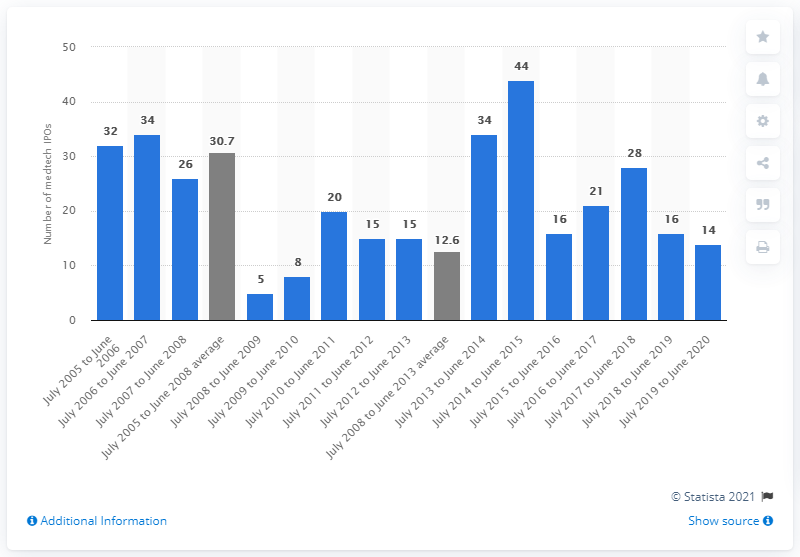Specify some key components in this picture. In the three years prior to the financial crisis, the average number of medtech initial public offerings (IPOs) was 30.7. 